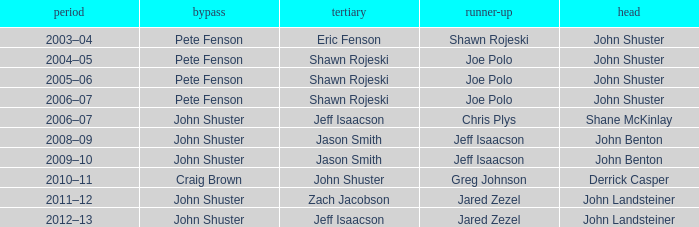Give me the full table as a dictionary. {'header': ['period', 'bypass', 'tertiary', 'runner-up', 'head'], 'rows': [['2003–04', 'Pete Fenson', 'Eric Fenson', 'Shawn Rojeski', 'John Shuster'], ['2004–05', 'Pete Fenson', 'Shawn Rojeski', 'Joe Polo', 'John Shuster'], ['2005–06', 'Pete Fenson', 'Shawn Rojeski', 'Joe Polo', 'John Shuster'], ['2006–07', 'Pete Fenson', 'Shawn Rojeski', 'Joe Polo', 'John Shuster'], ['2006–07', 'John Shuster', 'Jeff Isaacson', 'Chris Plys', 'Shane McKinlay'], ['2008–09', 'John Shuster', 'Jason Smith', 'Jeff Isaacson', 'John Benton'], ['2009–10', 'John Shuster', 'Jason Smith', 'Jeff Isaacson', 'John Benton'], ['2010–11', 'Craig Brown', 'John Shuster', 'Greg Johnson', 'Derrick Casper'], ['2011–12', 'John Shuster', 'Zach Jacobson', 'Jared Zezel', 'John Landsteiner'], ['2012–13', 'John Shuster', 'Jeff Isaacson', 'Jared Zezel', 'John Landsteiner']]} Who was the lead with Pete Fenson as skip and Joe Polo as second in season 2005–06? John Shuster. 